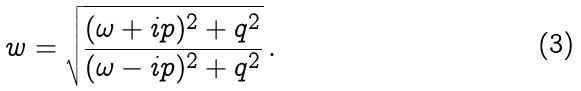Convert formula to latex. <formula><loc_0><loc_0><loc_500><loc_500>w = \sqrt { \frac { ( \omega + i p ) ^ { 2 } + q ^ { 2 } } { ( \omega - i p ) ^ { 2 } + q ^ { 2 } } } \, .</formula> 